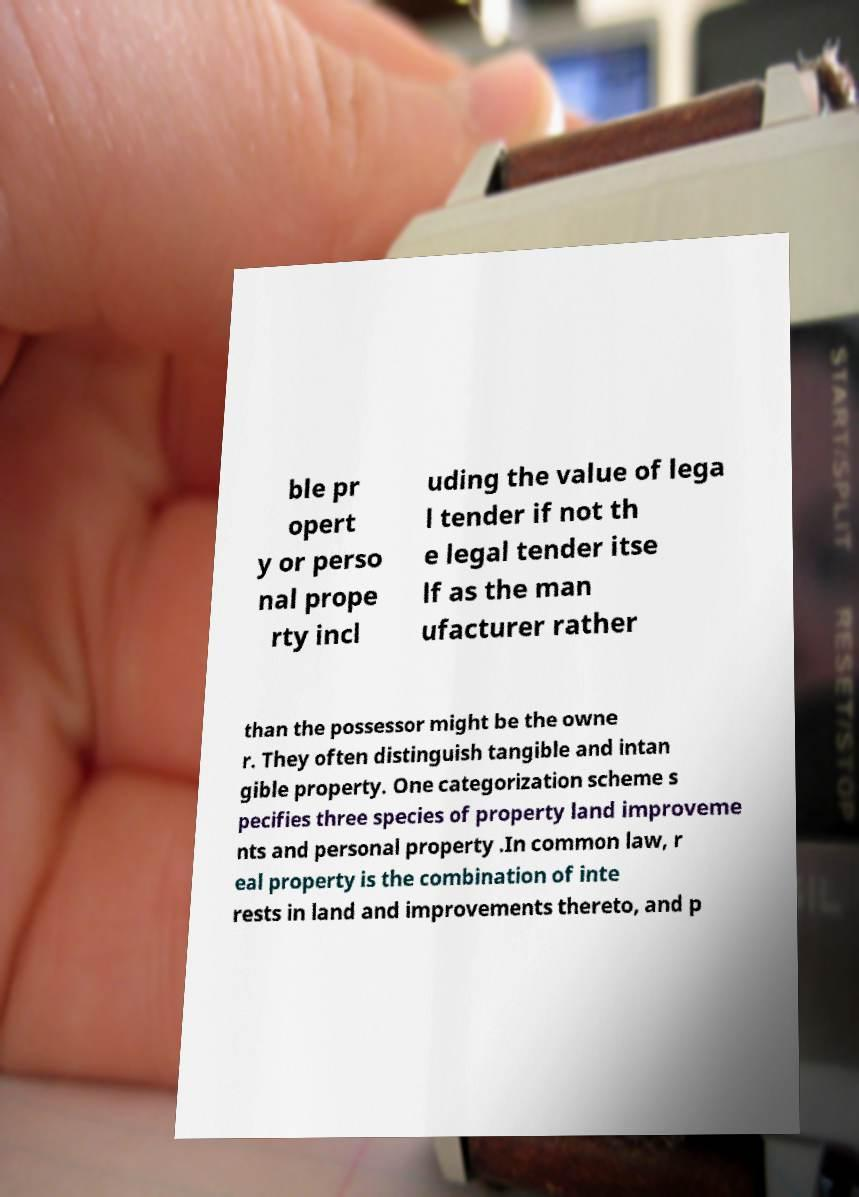Please identify and transcribe the text found in this image. ble pr opert y or perso nal prope rty incl uding the value of lega l tender if not th e legal tender itse lf as the man ufacturer rather than the possessor might be the owne r. They often distinguish tangible and intan gible property. One categorization scheme s pecifies three species of property land improveme nts and personal property .In common law, r eal property is the combination of inte rests in land and improvements thereto, and p 